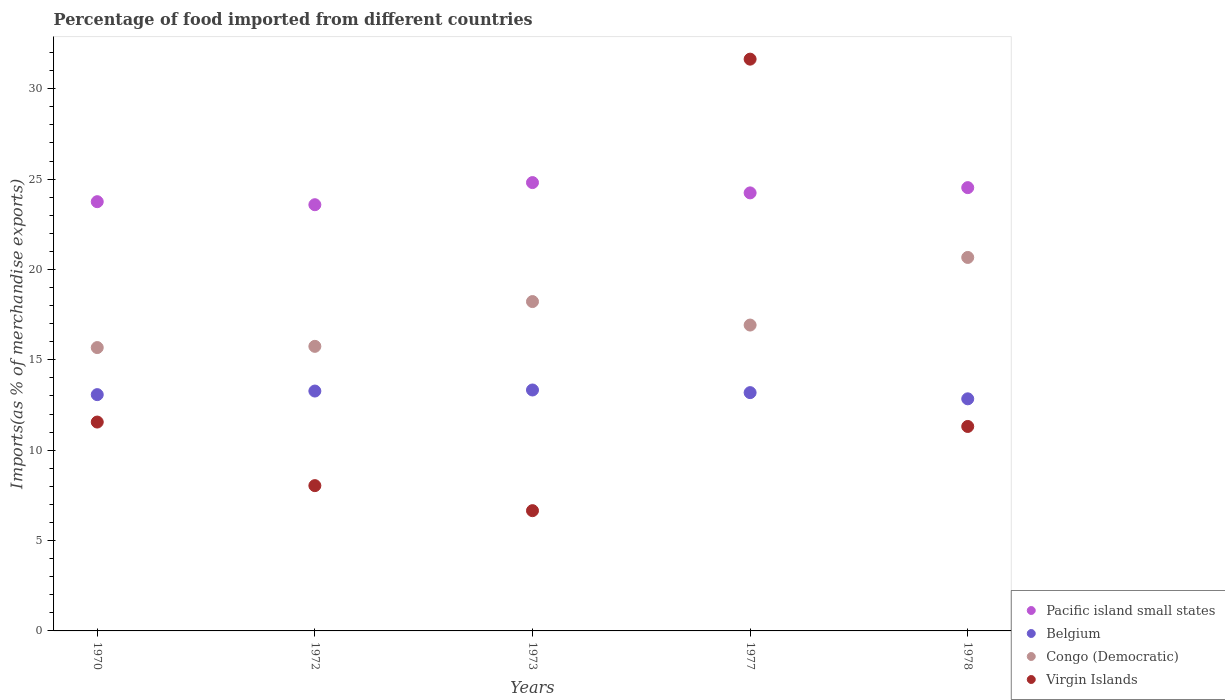How many different coloured dotlines are there?
Your answer should be very brief. 4. Is the number of dotlines equal to the number of legend labels?
Ensure brevity in your answer.  Yes. What is the percentage of imports to different countries in Congo (Democratic) in 1978?
Ensure brevity in your answer.  20.67. Across all years, what is the maximum percentage of imports to different countries in Belgium?
Offer a very short reply. 13.33. Across all years, what is the minimum percentage of imports to different countries in Belgium?
Give a very brief answer. 12.84. In which year was the percentage of imports to different countries in Virgin Islands maximum?
Offer a terse response. 1977. What is the total percentage of imports to different countries in Virgin Islands in the graph?
Your answer should be very brief. 69.21. What is the difference between the percentage of imports to different countries in Congo (Democratic) in 1972 and that in 1973?
Provide a succinct answer. -2.48. What is the difference between the percentage of imports to different countries in Virgin Islands in 1973 and the percentage of imports to different countries in Belgium in 1977?
Provide a succinct answer. -6.53. What is the average percentage of imports to different countries in Pacific island small states per year?
Offer a very short reply. 24.18. In the year 1973, what is the difference between the percentage of imports to different countries in Virgin Islands and percentage of imports to different countries in Pacific island small states?
Offer a very short reply. -18.15. In how many years, is the percentage of imports to different countries in Belgium greater than 2 %?
Make the answer very short. 5. What is the ratio of the percentage of imports to different countries in Virgin Islands in 1970 to that in 1978?
Provide a succinct answer. 1.02. What is the difference between the highest and the second highest percentage of imports to different countries in Belgium?
Your response must be concise. 0.06. What is the difference between the highest and the lowest percentage of imports to different countries in Pacific island small states?
Offer a very short reply. 1.22. Is it the case that in every year, the sum of the percentage of imports to different countries in Congo (Democratic) and percentage of imports to different countries in Belgium  is greater than the sum of percentage of imports to different countries in Pacific island small states and percentage of imports to different countries in Virgin Islands?
Make the answer very short. No. Is it the case that in every year, the sum of the percentage of imports to different countries in Belgium and percentage of imports to different countries in Pacific island small states  is greater than the percentage of imports to different countries in Congo (Democratic)?
Give a very brief answer. Yes. Does the percentage of imports to different countries in Virgin Islands monotonically increase over the years?
Offer a terse response. No. Is the percentage of imports to different countries in Congo (Democratic) strictly greater than the percentage of imports to different countries in Virgin Islands over the years?
Your response must be concise. No. Is the percentage of imports to different countries in Belgium strictly less than the percentage of imports to different countries in Virgin Islands over the years?
Offer a very short reply. No. What is the difference between two consecutive major ticks on the Y-axis?
Provide a short and direct response. 5. Does the graph contain any zero values?
Offer a very short reply. No. Does the graph contain grids?
Make the answer very short. No. Where does the legend appear in the graph?
Offer a very short reply. Bottom right. How are the legend labels stacked?
Your answer should be compact. Vertical. What is the title of the graph?
Your answer should be very brief. Percentage of food imported from different countries. What is the label or title of the Y-axis?
Keep it short and to the point. Imports(as % of merchandise exports). What is the Imports(as % of merchandise exports) in Pacific island small states in 1970?
Your answer should be very brief. 23.75. What is the Imports(as % of merchandise exports) of Belgium in 1970?
Offer a very short reply. 13.08. What is the Imports(as % of merchandise exports) in Congo (Democratic) in 1970?
Offer a terse response. 15.68. What is the Imports(as % of merchandise exports) in Virgin Islands in 1970?
Your answer should be very brief. 11.56. What is the Imports(as % of merchandise exports) in Pacific island small states in 1972?
Ensure brevity in your answer.  23.58. What is the Imports(as % of merchandise exports) of Belgium in 1972?
Your answer should be compact. 13.27. What is the Imports(as % of merchandise exports) of Congo (Democratic) in 1972?
Give a very brief answer. 15.75. What is the Imports(as % of merchandise exports) of Virgin Islands in 1972?
Provide a short and direct response. 8.04. What is the Imports(as % of merchandise exports) in Pacific island small states in 1973?
Offer a terse response. 24.81. What is the Imports(as % of merchandise exports) of Belgium in 1973?
Provide a short and direct response. 13.33. What is the Imports(as % of merchandise exports) in Congo (Democratic) in 1973?
Offer a terse response. 18.22. What is the Imports(as % of merchandise exports) of Virgin Islands in 1973?
Your response must be concise. 6.65. What is the Imports(as % of merchandise exports) in Pacific island small states in 1977?
Provide a short and direct response. 24.24. What is the Imports(as % of merchandise exports) in Belgium in 1977?
Ensure brevity in your answer.  13.19. What is the Imports(as % of merchandise exports) in Congo (Democratic) in 1977?
Make the answer very short. 16.93. What is the Imports(as % of merchandise exports) in Virgin Islands in 1977?
Offer a terse response. 31.64. What is the Imports(as % of merchandise exports) of Pacific island small states in 1978?
Provide a succinct answer. 24.53. What is the Imports(as % of merchandise exports) in Belgium in 1978?
Give a very brief answer. 12.84. What is the Imports(as % of merchandise exports) in Congo (Democratic) in 1978?
Your answer should be very brief. 20.67. What is the Imports(as % of merchandise exports) in Virgin Islands in 1978?
Your answer should be compact. 11.31. Across all years, what is the maximum Imports(as % of merchandise exports) in Pacific island small states?
Ensure brevity in your answer.  24.81. Across all years, what is the maximum Imports(as % of merchandise exports) in Belgium?
Your answer should be very brief. 13.33. Across all years, what is the maximum Imports(as % of merchandise exports) of Congo (Democratic)?
Keep it short and to the point. 20.67. Across all years, what is the maximum Imports(as % of merchandise exports) of Virgin Islands?
Offer a terse response. 31.64. Across all years, what is the minimum Imports(as % of merchandise exports) of Pacific island small states?
Provide a succinct answer. 23.58. Across all years, what is the minimum Imports(as % of merchandise exports) of Belgium?
Make the answer very short. 12.84. Across all years, what is the minimum Imports(as % of merchandise exports) of Congo (Democratic)?
Your response must be concise. 15.68. Across all years, what is the minimum Imports(as % of merchandise exports) in Virgin Islands?
Ensure brevity in your answer.  6.65. What is the total Imports(as % of merchandise exports) in Pacific island small states in the graph?
Your response must be concise. 120.91. What is the total Imports(as % of merchandise exports) in Belgium in the graph?
Your answer should be compact. 65.71. What is the total Imports(as % of merchandise exports) in Congo (Democratic) in the graph?
Your answer should be compact. 87.24. What is the total Imports(as % of merchandise exports) of Virgin Islands in the graph?
Your answer should be very brief. 69.21. What is the difference between the Imports(as % of merchandise exports) in Pacific island small states in 1970 and that in 1972?
Provide a succinct answer. 0.17. What is the difference between the Imports(as % of merchandise exports) in Belgium in 1970 and that in 1972?
Provide a short and direct response. -0.2. What is the difference between the Imports(as % of merchandise exports) in Congo (Democratic) in 1970 and that in 1972?
Keep it short and to the point. -0.07. What is the difference between the Imports(as % of merchandise exports) of Virgin Islands in 1970 and that in 1972?
Ensure brevity in your answer.  3.52. What is the difference between the Imports(as % of merchandise exports) in Pacific island small states in 1970 and that in 1973?
Keep it short and to the point. -1.06. What is the difference between the Imports(as % of merchandise exports) in Belgium in 1970 and that in 1973?
Provide a short and direct response. -0.26. What is the difference between the Imports(as % of merchandise exports) of Congo (Democratic) in 1970 and that in 1973?
Your answer should be compact. -2.55. What is the difference between the Imports(as % of merchandise exports) of Virgin Islands in 1970 and that in 1973?
Provide a short and direct response. 4.9. What is the difference between the Imports(as % of merchandise exports) in Pacific island small states in 1970 and that in 1977?
Make the answer very short. -0.49. What is the difference between the Imports(as % of merchandise exports) in Belgium in 1970 and that in 1977?
Offer a very short reply. -0.11. What is the difference between the Imports(as % of merchandise exports) of Congo (Democratic) in 1970 and that in 1977?
Your answer should be compact. -1.25. What is the difference between the Imports(as % of merchandise exports) of Virgin Islands in 1970 and that in 1977?
Provide a succinct answer. -20.08. What is the difference between the Imports(as % of merchandise exports) of Pacific island small states in 1970 and that in 1978?
Provide a short and direct response. -0.78. What is the difference between the Imports(as % of merchandise exports) of Belgium in 1970 and that in 1978?
Keep it short and to the point. 0.23. What is the difference between the Imports(as % of merchandise exports) in Congo (Democratic) in 1970 and that in 1978?
Offer a terse response. -4.99. What is the difference between the Imports(as % of merchandise exports) of Virgin Islands in 1970 and that in 1978?
Offer a very short reply. 0.24. What is the difference between the Imports(as % of merchandise exports) of Pacific island small states in 1972 and that in 1973?
Your answer should be compact. -1.22. What is the difference between the Imports(as % of merchandise exports) in Belgium in 1972 and that in 1973?
Provide a short and direct response. -0.06. What is the difference between the Imports(as % of merchandise exports) of Congo (Democratic) in 1972 and that in 1973?
Offer a very short reply. -2.48. What is the difference between the Imports(as % of merchandise exports) in Virgin Islands in 1972 and that in 1973?
Your answer should be compact. 1.39. What is the difference between the Imports(as % of merchandise exports) of Pacific island small states in 1972 and that in 1977?
Ensure brevity in your answer.  -0.65. What is the difference between the Imports(as % of merchandise exports) of Belgium in 1972 and that in 1977?
Your answer should be very brief. 0.09. What is the difference between the Imports(as % of merchandise exports) in Congo (Democratic) in 1972 and that in 1977?
Keep it short and to the point. -1.18. What is the difference between the Imports(as % of merchandise exports) in Virgin Islands in 1972 and that in 1977?
Make the answer very short. -23.6. What is the difference between the Imports(as % of merchandise exports) of Pacific island small states in 1972 and that in 1978?
Your answer should be very brief. -0.94. What is the difference between the Imports(as % of merchandise exports) in Belgium in 1972 and that in 1978?
Your response must be concise. 0.43. What is the difference between the Imports(as % of merchandise exports) of Congo (Democratic) in 1972 and that in 1978?
Make the answer very short. -4.92. What is the difference between the Imports(as % of merchandise exports) in Virgin Islands in 1972 and that in 1978?
Offer a terse response. -3.27. What is the difference between the Imports(as % of merchandise exports) of Pacific island small states in 1973 and that in 1977?
Ensure brevity in your answer.  0.57. What is the difference between the Imports(as % of merchandise exports) of Belgium in 1973 and that in 1977?
Your answer should be very brief. 0.15. What is the difference between the Imports(as % of merchandise exports) of Congo (Democratic) in 1973 and that in 1977?
Offer a very short reply. 1.3. What is the difference between the Imports(as % of merchandise exports) of Virgin Islands in 1973 and that in 1977?
Provide a short and direct response. -24.98. What is the difference between the Imports(as % of merchandise exports) in Pacific island small states in 1973 and that in 1978?
Your answer should be very brief. 0.28. What is the difference between the Imports(as % of merchandise exports) in Belgium in 1973 and that in 1978?
Your response must be concise. 0.49. What is the difference between the Imports(as % of merchandise exports) in Congo (Democratic) in 1973 and that in 1978?
Provide a short and direct response. -2.44. What is the difference between the Imports(as % of merchandise exports) of Virgin Islands in 1973 and that in 1978?
Make the answer very short. -4.66. What is the difference between the Imports(as % of merchandise exports) in Pacific island small states in 1977 and that in 1978?
Make the answer very short. -0.29. What is the difference between the Imports(as % of merchandise exports) of Belgium in 1977 and that in 1978?
Your answer should be compact. 0.34. What is the difference between the Imports(as % of merchandise exports) in Congo (Democratic) in 1977 and that in 1978?
Keep it short and to the point. -3.74. What is the difference between the Imports(as % of merchandise exports) of Virgin Islands in 1977 and that in 1978?
Your response must be concise. 20.33. What is the difference between the Imports(as % of merchandise exports) of Pacific island small states in 1970 and the Imports(as % of merchandise exports) of Belgium in 1972?
Offer a very short reply. 10.48. What is the difference between the Imports(as % of merchandise exports) of Pacific island small states in 1970 and the Imports(as % of merchandise exports) of Congo (Democratic) in 1972?
Keep it short and to the point. 8.01. What is the difference between the Imports(as % of merchandise exports) of Pacific island small states in 1970 and the Imports(as % of merchandise exports) of Virgin Islands in 1972?
Your answer should be compact. 15.71. What is the difference between the Imports(as % of merchandise exports) in Belgium in 1970 and the Imports(as % of merchandise exports) in Congo (Democratic) in 1972?
Provide a short and direct response. -2.67. What is the difference between the Imports(as % of merchandise exports) of Belgium in 1970 and the Imports(as % of merchandise exports) of Virgin Islands in 1972?
Your answer should be very brief. 5.04. What is the difference between the Imports(as % of merchandise exports) in Congo (Democratic) in 1970 and the Imports(as % of merchandise exports) in Virgin Islands in 1972?
Offer a very short reply. 7.64. What is the difference between the Imports(as % of merchandise exports) of Pacific island small states in 1970 and the Imports(as % of merchandise exports) of Belgium in 1973?
Offer a terse response. 10.42. What is the difference between the Imports(as % of merchandise exports) of Pacific island small states in 1970 and the Imports(as % of merchandise exports) of Congo (Democratic) in 1973?
Your answer should be very brief. 5.53. What is the difference between the Imports(as % of merchandise exports) of Pacific island small states in 1970 and the Imports(as % of merchandise exports) of Virgin Islands in 1973?
Keep it short and to the point. 17.1. What is the difference between the Imports(as % of merchandise exports) in Belgium in 1970 and the Imports(as % of merchandise exports) in Congo (Democratic) in 1973?
Ensure brevity in your answer.  -5.15. What is the difference between the Imports(as % of merchandise exports) in Belgium in 1970 and the Imports(as % of merchandise exports) in Virgin Islands in 1973?
Provide a short and direct response. 6.42. What is the difference between the Imports(as % of merchandise exports) in Congo (Democratic) in 1970 and the Imports(as % of merchandise exports) in Virgin Islands in 1973?
Your answer should be compact. 9.02. What is the difference between the Imports(as % of merchandise exports) of Pacific island small states in 1970 and the Imports(as % of merchandise exports) of Belgium in 1977?
Keep it short and to the point. 10.57. What is the difference between the Imports(as % of merchandise exports) in Pacific island small states in 1970 and the Imports(as % of merchandise exports) in Congo (Democratic) in 1977?
Provide a short and direct response. 6.83. What is the difference between the Imports(as % of merchandise exports) of Pacific island small states in 1970 and the Imports(as % of merchandise exports) of Virgin Islands in 1977?
Your answer should be compact. -7.89. What is the difference between the Imports(as % of merchandise exports) of Belgium in 1970 and the Imports(as % of merchandise exports) of Congo (Democratic) in 1977?
Offer a very short reply. -3.85. What is the difference between the Imports(as % of merchandise exports) of Belgium in 1970 and the Imports(as % of merchandise exports) of Virgin Islands in 1977?
Offer a terse response. -18.56. What is the difference between the Imports(as % of merchandise exports) of Congo (Democratic) in 1970 and the Imports(as % of merchandise exports) of Virgin Islands in 1977?
Your answer should be compact. -15.96. What is the difference between the Imports(as % of merchandise exports) in Pacific island small states in 1970 and the Imports(as % of merchandise exports) in Belgium in 1978?
Give a very brief answer. 10.91. What is the difference between the Imports(as % of merchandise exports) in Pacific island small states in 1970 and the Imports(as % of merchandise exports) in Congo (Democratic) in 1978?
Offer a very short reply. 3.09. What is the difference between the Imports(as % of merchandise exports) of Pacific island small states in 1970 and the Imports(as % of merchandise exports) of Virgin Islands in 1978?
Offer a terse response. 12.44. What is the difference between the Imports(as % of merchandise exports) of Belgium in 1970 and the Imports(as % of merchandise exports) of Congo (Democratic) in 1978?
Keep it short and to the point. -7.59. What is the difference between the Imports(as % of merchandise exports) of Belgium in 1970 and the Imports(as % of merchandise exports) of Virgin Islands in 1978?
Ensure brevity in your answer.  1.76. What is the difference between the Imports(as % of merchandise exports) of Congo (Democratic) in 1970 and the Imports(as % of merchandise exports) of Virgin Islands in 1978?
Your answer should be compact. 4.37. What is the difference between the Imports(as % of merchandise exports) of Pacific island small states in 1972 and the Imports(as % of merchandise exports) of Belgium in 1973?
Provide a short and direct response. 10.25. What is the difference between the Imports(as % of merchandise exports) in Pacific island small states in 1972 and the Imports(as % of merchandise exports) in Congo (Democratic) in 1973?
Provide a short and direct response. 5.36. What is the difference between the Imports(as % of merchandise exports) in Pacific island small states in 1972 and the Imports(as % of merchandise exports) in Virgin Islands in 1973?
Offer a terse response. 16.93. What is the difference between the Imports(as % of merchandise exports) in Belgium in 1972 and the Imports(as % of merchandise exports) in Congo (Democratic) in 1973?
Ensure brevity in your answer.  -4.95. What is the difference between the Imports(as % of merchandise exports) of Belgium in 1972 and the Imports(as % of merchandise exports) of Virgin Islands in 1973?
Offer a terse response. 6.62. What is the difference between the Imports(as % of merchandise exports) in Congo (Democratic) in 1972 and the Imports(as % of merchandise exports) in Virgin Islands in 1973?
Your answer should be very brief. 9.09. What is the difference between the Imports(as % of merchandise exports) of Pacific island small states in 1972 and the Imports(as % of merchandise exports) of Belgium in 1977?
Make the answer very short. 10.4. What is the difference between the Imports(as % of merchandise exports) in Pacific island small states in 1972 and the Imports(as % of merchandise exports) in Congo (Democratic) in 1977?
Keep it short and to the point. 6.66. What is the difference between the Imports(as % of merchandise exports) in Pacific island small states in 1972 and the Imports(as % of merchandise exports) in Virgin Islands in 1977?
Give a very brief answer. -8.05. What is the difference between the Imports(as % of merchandise exports) in Belgium in 1972 and the Imports(as % of merchandise exports) in Congo (Democratic) in 1977?
Your response must be concise. -3.65. What is the difference between the Imports(as % of merchandise exports) of Belgium in 1972 and the Imports(as % of merchandise exports) of Virgin Islands in 1977?
Your response must be concise. -18.37. What is the difference between the Imports(as % of merchandise exports) in Congo (Democratic) in 1972 and the Imports(as % of merchandise exports) in Virgin Islands in 1977?
Provide a short and direct response. -15.89. What is the difference between the Imports(as % of merchandise exports) in Pacific island small states in 1972 and the Imports(as % of merchandise exports) in Belgium in 1978?
Provide a short and direct response. 10.74. What is the difference between the Imports(as % of merchandise exports) in Pacific island small states in 1972 and the Imports(as % of merchandise exports) in Congo (Democratic) in 1978?
Offer a very short reply. 2.92. What is the difference between the Imports(as % of merchandise exports) of Pacific island small states in 1972 and the Imports(as % of merchandise exports) of Virgin Islands in 1978?
Provide a short and direct response. 12.27. What is the difference between the Imports(as % of merchandise exports) in Belgium in 1972 and the Imports(as % of merchandise exports) in Congo (Democratic) in 1978?
Provide a short and direct response. -7.39. What is the difference between the Imports(as % of merchandise exports) in Belgium in 1972 and the Imports(as % of merchandise exports) in Virgin Islands in 1978?
Provide a succinct answer. 1.96. What is the difference between the Imports(as % of merchandise exports) of Congo (Democratic) in 1972 and the Imports(as % of merchandise exports) of Virgin Islands in 1978?
Your response must be concise. 4.43. What is the difference between the Imports(as % of merchandise exports) of Pacific island small states in 1973 and the Imports(as % of merchandise exports) of Belgium in 1977?
Your answer should be compact. 11.62. What is the difference between the Imports(as % of merchandise exports) of Pacific island small states in 1973 and the Imports(as % of merchandise exports) of Congo (Democratic) in 1977?
Make the answer very short. 7.88. What is the difference between the Imports(as % of merchandise exports) of Pacific island small states in 1973 and the Imports(as % of merchandise exports) of Virgin Islands in 1977?
Your response must be concise. -6.83. What is the difference between the Imports(as % of merchandise exports) of Belgium in 1973 and the Imports(as % of merchandise exports) of Congo (Democratic) in 1977?
Your response must be concise. -3.59. What is the difference between the Imports(as % of merchandise exports) of Belgium in 1973 and the Imports(as % of merchandise exports) of Virgin Islands in 1977?
Provide a short and direct response. -18.31. What is the difference between the Imports(as % of merchandise exports) of Congo (Democratic) in 1973 and the Imports(as % of merchandise exports) of Virgin Islands in 1977?
Offer a terse response. -13.41. What is the difference between the Imports(as % of merchandise exports) of Pacific island small states in 1973 and the Imports(as % of merchandise exports) of Belgium in 1978?
Your response must be concise. 11.97. What is the difference between the Imports(as % of merchandise exports) of Pacific island small states in 1973 and the Imports(as % of merchandise exports) of Congo (Democratic) in 1978?
Your response must be concise. 4.14. What is the difference between the Imports(as % of merchandise exports) of Pacific island small states in 1973 and the Imports(as % of merchandise exports) of Virgin Islands in 1978?
Your response must be concise. 13.5. What is the difference between the Imports(as % of merchandise exports) in Belgium in 1973 and the Imports(as % of merchandise exports) in Congo (Democratic) in 1978?
Keep it short and to the point. -7.33. What is the difference between the Imports(as % of merchandise exports) of Belgium in 1973 and the Imports(as % of merchandise exports) of Virgin Islands in 1978?
Make the answer very short. 2.02. What is the difference between the Imports(as % of merchandise exports) in Congo (Democratic) in 1973 and the Imports(as % of merchandise exports) in Virgin Islands in 1978?
Offer a very short reply. 6.91. What is the difference between the Imports(as % of merchandise exports) in Pacific island small states in 1977 and the Imports(as % of merchandise exports) in Belgium in 1978?
Give a very brief answer. 11.4. What is the difference between the Imports(as % of merchandise exports) of Pacific island small states in 1977 and the Imports(as % of merchandise exports) of Congo (Democratic) in 1978?
Provide a succinct answer. 3.57. What is the difference between the Imports(as % of merchandise exports) in Pacific island small states in 1977 and the Imports(as % of merchandise exports) in Virgin Islands in 1978?
Make the answer very short. 12.93. What is the difference between the Imports(as % of merchandise exports) of Belgium in 1977 and the Imports(as % of merchandise exports) of Congo (Democratic) in 1978?
Your answer should be compact. -7.48. What is the difference between the Imports(as % of merchandise exports) of Belgium in 1977 and the Imports(as % of merchandise exports) of Virgin Islands in 1978?
Provide a short and direct response. 1.87. What is the difference between the Imports(as % of merchandise exports) in Congo (Democratic) in 1977 and the Imports(as % of merchandise exports) in Virgin Islands in 1978?
Keep it short and to the point. 5.61. What is the average Imports(as % of merchandise exports) in Pacific island small states per year?
Your response must be concise. 24.18. What is the average Imports(as % of merchandise exports) of Belgium per year?
Keep it short and to the point. 13.14. What is the average Imports(as % of merchandise exports) of Congo (Democratic) per year?
Offer a terse response. 17.45. What is the average Imports(as % of merchandise exports) of Virgin Islands per year?
Your answer should be compact. 13.84. In the year 1970, what is the difference between the Imports(as % of merchandise exports) in Pacific island small states and Imports(as % of merchandise exports) in Belgium?
Offer a very short reply. 10.68. In the year 1970, what is the difference between the Imports(as % of merchandise exports) in Pacific island small states and Imports(as % of merchandise exports) in Congo (Democratic)?
Make the answer very short. 8.07. In the year 1970, what is the difference between the Imports(as % of merchandise exports) of Pacific island small states and Imports(as % of merchandise exports) of Virgin Islands?
Keep it short and to the point. 12.19. In the year 1970, what is the difference between the Imports(as % of merchandise exports) in Belgium and Imports(as % of merchandise exports) in Congo (Democratic)?
Your answer should be very brief. -2.6. In the year 1970, what is the difference between the Imports(as % of merchandise exports) of Belgium and Imports(as % of merchandise exports) of Virgin Islands?
Make the answer very short. 1.52. In the year 1970, what is the difference between the Imports(as % of merchandise exports) in Congo (Democratic) and Imports(as % of merchandise exports) in Virgin Islands?
Your response must be concise. 4.12. In the year 1972, what is the difference between the Imports(as % of merchandise exports) in Pacific island small states and Imports(as % of merchandise exports) in Belgium?
Give a very brief answer. 10.31. In the year 1972, what is the difference between the Imports(as % of merchandise exports) in Pacific island small states and Imports(as % of merchandise exports) in Congo (Democratic)?
Give a very brief answer. 7.84. In the year 1972, what is the difference between the Imports(as % of merchandise exports) of Pacific island small states and Imports(as % of merchandise exports) of Virgin Islands?
Give a very brief answer. 15.54. In the year 1972, what is the difference between the Imports(as % of merchandise exports) of Belgium and Imports(as % of merchandise exports) of Congo (Democratic)?
Your response must be concise. -2.47. In the year 1972, what is the difference between the Imports(as % of merchandise exports) in Belgium and Imports(as % of merchandise exports) in Virgin Islands?
Offer a very short reply. 5.23. In the year 1972, what is the difference between the Imports(as % of merchandise exports) of Congo (Democratic) and Imports(as % of merchandise exports) of Virgin Islands?
Your answer should be compact. 7.71. In the year 1973, what is the difference between the Imports(as % of merchandise exports) in Pacific island small states and Imports(as % of merchandise exports) in Belgium?
Your answer should be compact. 11.48. In the year 1973, what is the difference between the Imports(as % of merchandise exports) of Pacific island small states and Imports(as % of merchandise exports) of Congo (Democratic)?
Give a very brief answer. 6.58. In the year 1973, what is the difference between the Imports(as % of merchandise exports) in Pacific island small states and Imports(as % of merchandise exports) in Virgin Islands?
Your response must be concise. 18.15. In the year 1973, what is the difference between the Imports(as % of merchandise exports) of Belgium and Imports(as % of merchandise exports) of Congo (Democratic)?
Your response must be concise. -4.89. In the year 1973, what is the difference between the Imports(as % of merchandise exports) in Belgium and Imports(as % of merchandise exports) in Virgin Islands?
Provide a short and direct response. 6.68. In the year 1973, what is the difference between the Imports(as % of merchandise exports) of Congo (Democratic) and Imports(as % of merchandise exports) of Virgin Islands?
Provide a short and direct response. 11.57. In the year 1977, what is the difference between the Imports(as % of merchandise exports) of Pacific island small states and Imports(as % of merchandise exports) of Belgium?
Your answer should be compact. 11.05. In the year 1977, what is the difference between the Imports(as % of merchandise exports) of Pacific island small states and Imports(as % of merchandise exports) of Congo (Democratic)?
Ensure brevity in your answer.  7.31. In the year 1977, what is the difference between the Imports(as % of merchandise exports) in Pacific island small states and Imports(as % of merchandise exports) in Virgin Islands?
Your answer should be compact. -7.4. In the year 1977, what is the difference between the Imports(as % of merchandise exports) of Belgium and Imports(as % of merchandise exports) of Congo (Democratic)?
Your response must be concise. -3.74. In the year 1977, what is the difference between the Imports(as % of merchandise exports) in Belgium and Imports(as % of merchandise exports) in Virgin Islands?
Provide a short and direct response. -18.45. In the year 1977, what is the difference between the Imports(as % of merchandise exports) in Congo (Democratic) and Imports(as % of merchandise exports) in Virgin Islands?
Your answer should be very brief. -14.71. In the year 1978, what is the difference between the Imports(as % of merchandise exports) of Pacific island small states and Imports(as % of merchandise exports) of Belgium?
Make the answer very short. 11.69. In the year 1978, what is the difference between the Imports(as % of merchandise exports) in Pacific island small states and Imports(as % of merchandise exports) in Congo (Democratic)?
Make the answer very short. 3.86. In the year 1978, what is the difference between the Imports(as % of merchandise exports) of Pacific island small states and Imports(as % of merchandise exports) of Virgin Islands?
Give a very brief answer. 13.22. In the year 1978, what is the difference between the Imports(as % of merchandise exports) of Belgium and Imports(as % of merchandise exports) of Congo (Democratic)?
Make the answer very short. -7.82. In the year 1978, what is the difference between the Imports(as % of merchandise exports) in Belgium and Imports(as % of merchandise exports) in Virgin Islands?
Ensure brevity in your answer.  1.53. In the year 1978, what is the difference between the Imports(as % of merchandise exports) in Congo (Democratic) and Imports(as % of merchandise exports) in Virgin Islands?
Provide a succinct answer. 9.35. What is the ratio of the Imports(as % of merchandise exports) in Pacific island small states in 1970 to that in 1972?
Ensure brevity in your answer.  1.01. What is the ratio of the Imports(as % of merchandise exports) in Belgium in 1970 to that in 1972?
Provide a short and direct response. 0.99. What is the ratio of the Imports(as % of merchandise exports) in Virgin Islands in 1970 to that in 1972?
Your answer should be compact. 1.44. What is the ratio of the Imports(as % of merchandise exports) in Pacific island small states in 1970 to that in 1973?
Provide a succinct answer. 0.96. What is the ratio of the Imports(as % of merchandise exports) in Belgium in 1970 to that in 1973?
Provide a short and direct response. 0.98. What is the ratio of the Imports(as % of merchandise exports) of Congo (Democratic) in 1970 to that in 1973?
Make the answer very short. 0.86. What is the ratio of the Imports(as % of merchandise exports) in Virgin Islands in 1970 to that in 1973?
Your answer should be very brief. 1.74. What is the ratio of the Imports(as % of merchandise exports) in Pacific island small states in 1970 to that in 1977?
Make the answer very short. 0.98. What is the ratio of the Imports(as % of merchandise exports) of Belgium in 1970 to that in 1977?
Provide a succinct answer. 0.99. What is the ratio of the Imports(as % of merchandise exports) of Congo (Democratic) in 1970 to that in 1977?
Offer a terse response. 0.93. What is the ratio of the Imports(as % of merchandise exports) in Virgin Islands in 1970 to that in 1977?
Provide a succinct answer. 0.37. What is the ratio of the Imports(as % of merchandise exports) of Pacific island small states in 1970 to that in 1978?
Your response must be concise. 0.97. What is the ratio of the Imports(as % of merchandise exports) in Belgium in 1970 to that in 1978?
Your answer should be compact. 1.02. What is the ratio of the Imports(as % of merchandise exports) of Congo (Democratic) in 1970 to that in 1978?
Offer a terse response. 0.76. What is the ratio of the Imports(as % of merchandise exports) of Virgin Islands in 1970 to that in 1978?
Offer a very short reply. 1.02. What is the ratio of the Imports(as % of merchandise exports) of Pacific island small states in 1972 to that in 1973?
Give a very brief answer. 0.95. What is the ratio of the Imports(as % of merchandise exports) in Congo (Democratic) in 1972 to that in 1973?
Your answer should be very brief. 0.86. What is the ratio of the Imports(as % of merchandise exports) of Virgin Islands in 1972 to that in 1973?
Ensure brevity in your answer.  1.21. What is the ratio of the Imports(as % of merchandise exports) in Belgium in 1972 to that in 1977?
Provide a succinct answer. 1.01. What is the ratio of the Imports(as % of merchandise exports) in Congo (Democratic) in 1972 to that in 1977?
Ensure brevity in your answer.  0.93. What is the ratio of the Imports(as % of merchandise exports) in Virgin Islands in 1972 to that in 1977?
Your answer should be compact. 0.25. What is the ratio of the Imports(as % of merchandise exports) in Pacific island small states in 1972 to that in 1978?
Your answer should be compact. 0.96. What is the ratio of the Imports(as % of merchandise exports) of Belgium in 1972 to that in 1978?
Offer a very short reply. 1.03. What is the ratio of the Imports(as % of merchandise exports) of Congo (Democratic) in 1972 to that in 1978?
Provide a short and direct response. 0.76. What is the ratio of the Imports(as % of merchandise exports) in Virgin Islands in 1972 to that in 1978?
Your response must be concise. 0.71. What is the ratio of the Imports(as % of merchandise exports) of Pacific island small states in 1973 to that in 1977?
Provide a short and direct response. 1.02. What is the ratio of the Imports(as % of merchandise exports) in Belgium in 1973 to that in 1977?
Keep it short and to the point. 1.01. What is the ratio of the Imports(as % of merchandise exports) in Congo (Democratic) in 1973 to that in 1977?
Keep it short and to the point. 1.08. What is the ratio of the Imports(as % of merchandise exports) of Virgin Islands in 1973 to that in 1977?
Offer a terse response. 0.21. What is the ratio of the Imports(as % of merchandise exports) of Pacific island small states in 1973 to that in 1978?
Provide a succinct answer. 1.01. What is the ratio of the Imports(as % of merchandise exports) of Belgium in 1973 to that in 1978?
Your answer should be compact. 1.04. What is the ratio of the Imports(as % of merchandise exports) of Congo (Democratic) in 1973 to that in 1978?
Provide a succinct answer. 0.88. What is the ratio of the Imports(as % of merchandise exports) in Virgin Islands in 1973 to that in 1978?
Provide a succinct answer. 0.59. What is the ratio of the Imports(as % of merchandise exports) of Pacific island small states in 1977 to that in 1978?
Give a very brief answer. 0.99. What is the ratio of the Imports(as % of merchandise exports) in Belgium in 1977 to that in 1978?
Provide a succinct answer. 1.03. What is the ratio of the Imports(as % of merchandise exports) in Congo (Democratic) in 1977 to that in 1978?
Offer a very short reply. 0.82. What is the ratio of the Imports(as % of merchandise exports) of Virgin Islands in 1977 to that in 1978?
Keep it short and to the point. 2.8. What is the difference between the highest and the second highest Imports(as % of merchandise exports) of Pacific island small states?
Your answer should be very brief. 0.28. What is the difference between the highest and the second highest Imports(as % of merchandise exports) of Belgium?
Ensure brevity in your answer.  0.06. What is the difference between the highest and the second highest Imports(as % of merchandise exports) in Congo (Democratic)?
Keep it short and to the point. 2.44. What is the difference between the highest and the second highest Imports(as % of merchandise exports) in Virgin Islands?
Ensure brevity in your answer.  20.08. What is the difference between the highest and the lowest Imports(as % of merchandise exports) in Pacific island small states?
Make the answer very short. 1.22. What is the difference between the highest and the lowest Imports(as % of merchandise exports) in Belgium?
Provide a succinct answer. 0.49. What is the difference between the highest and the lowest Imports(as % of merchandise exports) in Congo (Democratic)?
Offer a very short reply. 4.99. What is the difference between the highest and the lowest Imports(as % of merchandise exports) in Virgin Islands?
Offer a very short reply. 24.98. 